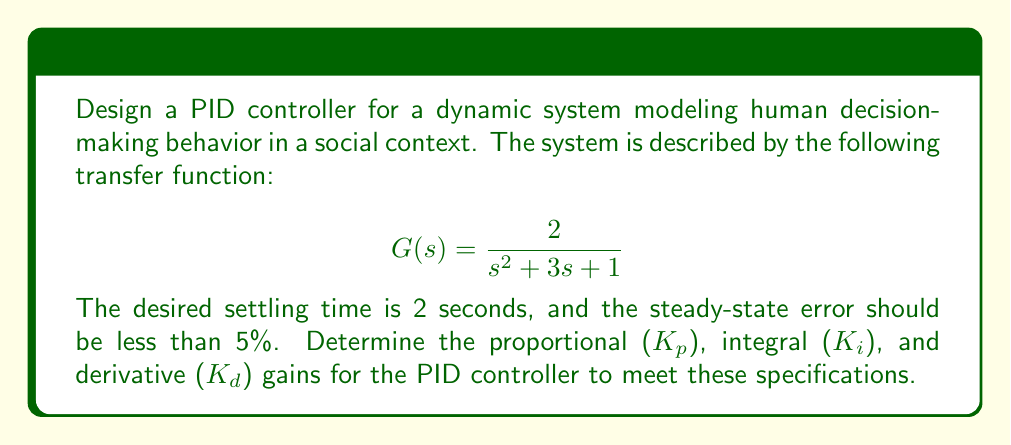Show me your answer to this math problem. To design a PID controller for this system, we'll follow these steps:

1. Determine the required damping ratio ($\zeta$) and natural frequency ($\omega_n$) based on the settling time.
2. Calculate the proportional gain ($K_p$) using the natural frequency.
3. Determine the integral gain ($K_i$) to minimize steady-state error.
4. Calculate the derivative gain ($K_d$) to achieve the desired damping ratio.

Step 1: Determine $\zeta$ and $\omega_n$
For a second-order system, the settling time ($t_s$) is related to $\zeta$ and $\omega_n$ by:

$$t_s \approx \frac{4}{\zeta \omega_n}$$

We'll assume a damping ratio of $\zeta = 0.707$ for a good balance between overshoot and settling time. With $t_s = 2$ seconds:

$$2 = \frac{4}{0.707 \omega_n}$$
$$\omega_n = \frac{4}{0.707 \cdot 2} \approx 2.83 \text{ rad/s}$$

Step 2: Calculate $K_p$
For a second-order system with PID control, the closed-loop transfer function is:

$$T(s) = \frac{K_p s^2 + K_i s + K_d}{s^3 + (3+K_d)s^2 + (1+K_p)s + K_i}$$

Comparing this to the standard form:

$$\frac{\omega_n^2}{s^2 + 2\zeta\omega_n s + \omega_n^2}$$

We can see that:

$$K_p = \omega_n^2 - 1 = 2.83^2 - 1 \approx 7$$

Step 3: Determine $K_i$
To minimize steady-state error, we need to include integral action. A good rule of thumb is to set $K_i = K_p / T_i$, where $T_i$ is the integral time constant. We'll choose $T_i = 1/\omega_n$:

$$K_i = K_p \cdot \omega_n = 7 \cdot 2.83 \approx 19.8$$

Step 4: Calculate $K_d$
To achieve the desired damping ratio, we need:

$$2\zeta\omega_n = 3 + K_d$$

Solving for $K_d$:

$$K_d = 2\zeta\omega_n - 3 = 2 \cdot 0.707 \cdot 2.83 - 3 \approx 1$$

These gains should provide a good starting point for tuning the PID controller to meet the specified requirements.
Answer: The PID controller gains for the given system are:

Proportional gain: $K_p \approx 7$
Integral gain: $K_i \approx 19.8$
Derivative gain: $K_d \approx 1$ 